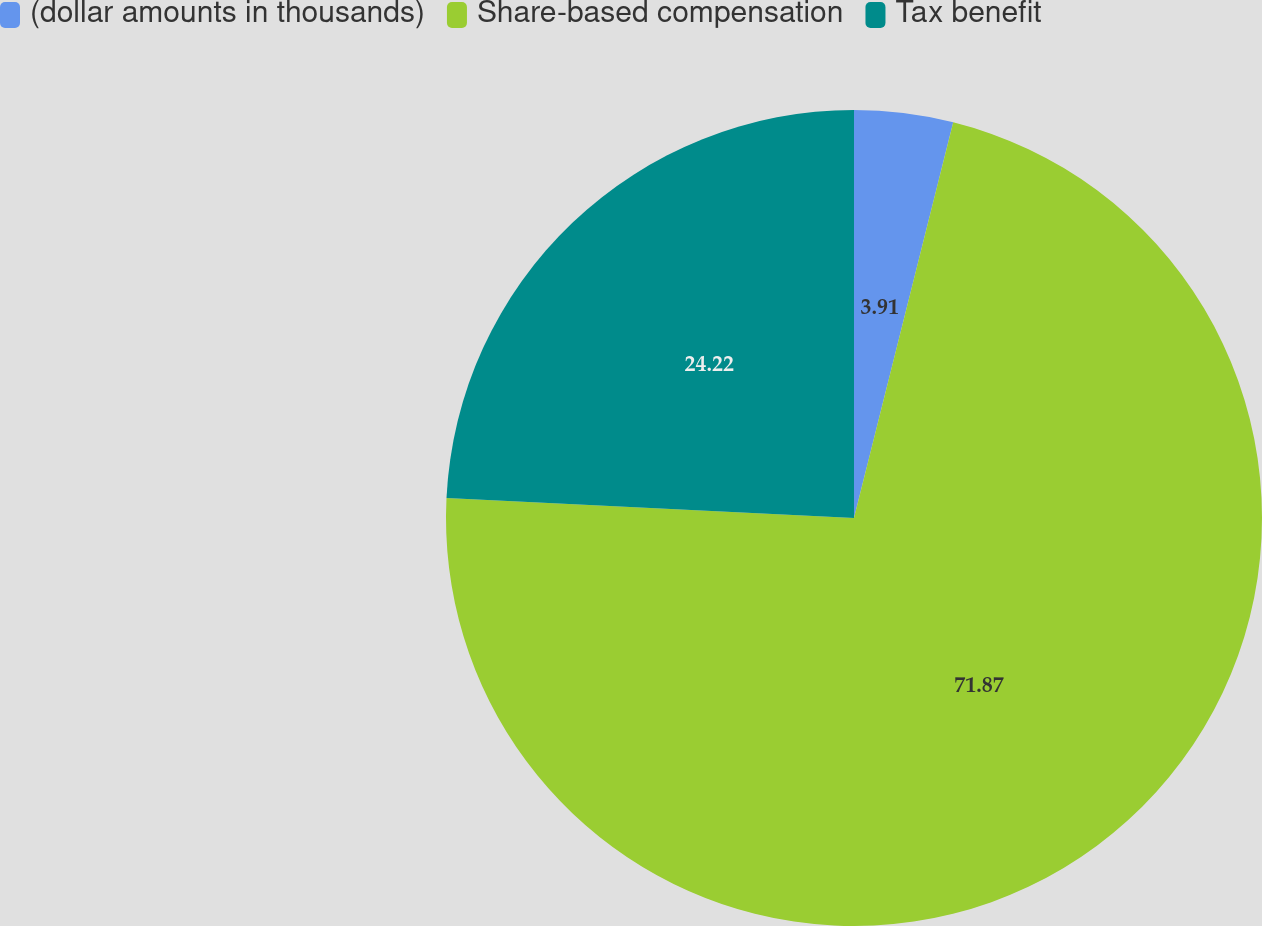Convert chart. <chart><loc_0><loc_0><loc_500><loc_500><pie_chart><fcel>(dollar amounts in thousands)<fcel>Share-based compensation<fcel>Tax benefit<nl><fcel>3.91%<fcel>71.87%<fcel>24.22%<nl></chart> 